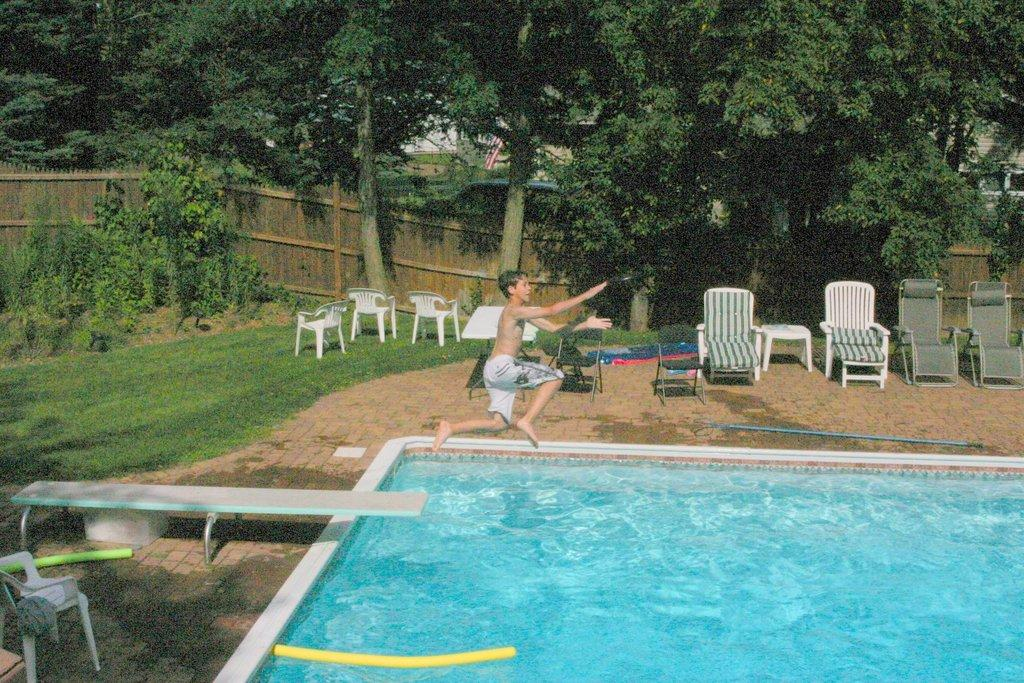What type of vegetation can be seen in the image? There are trees and plants in the image. What type of furniture is present in the image? There are chairs in the image. What is the jumping platform used for in the image? The jumping platform is on the left side of the image and is used for jumping into a pool. What activity is the kid engaged in within the image? There is a kid jumping in a pool in the image. What type of office furniture can be seen in the image? There is no office furniture present in the image. Can you see any fish swimming in the pool in the image? There are no fish visible in the image; it only shows a kid jumping in a pool. 